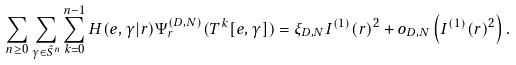<formula> <loc_0><loc_0><loc_500><loc_500>\sum _ { n \geq 0 } \sum _ { \gamma \in \hat { S } ^ { n } } \sum _ { k = 0 } ^ { n - 1 } H ( e , \gamma | r ) \Psi _ { r } ^ { ( D , N ) } ( T ^ { k } [ e , \gamma ] ) = \xi _ { D , N } I ^ { ( 1 ) } ( r ) ^ { 2 } + o _ { D , N } \left ( I ^ { ( 1 ) } ( r ) ^ { 2 } \right ) .</formula> 